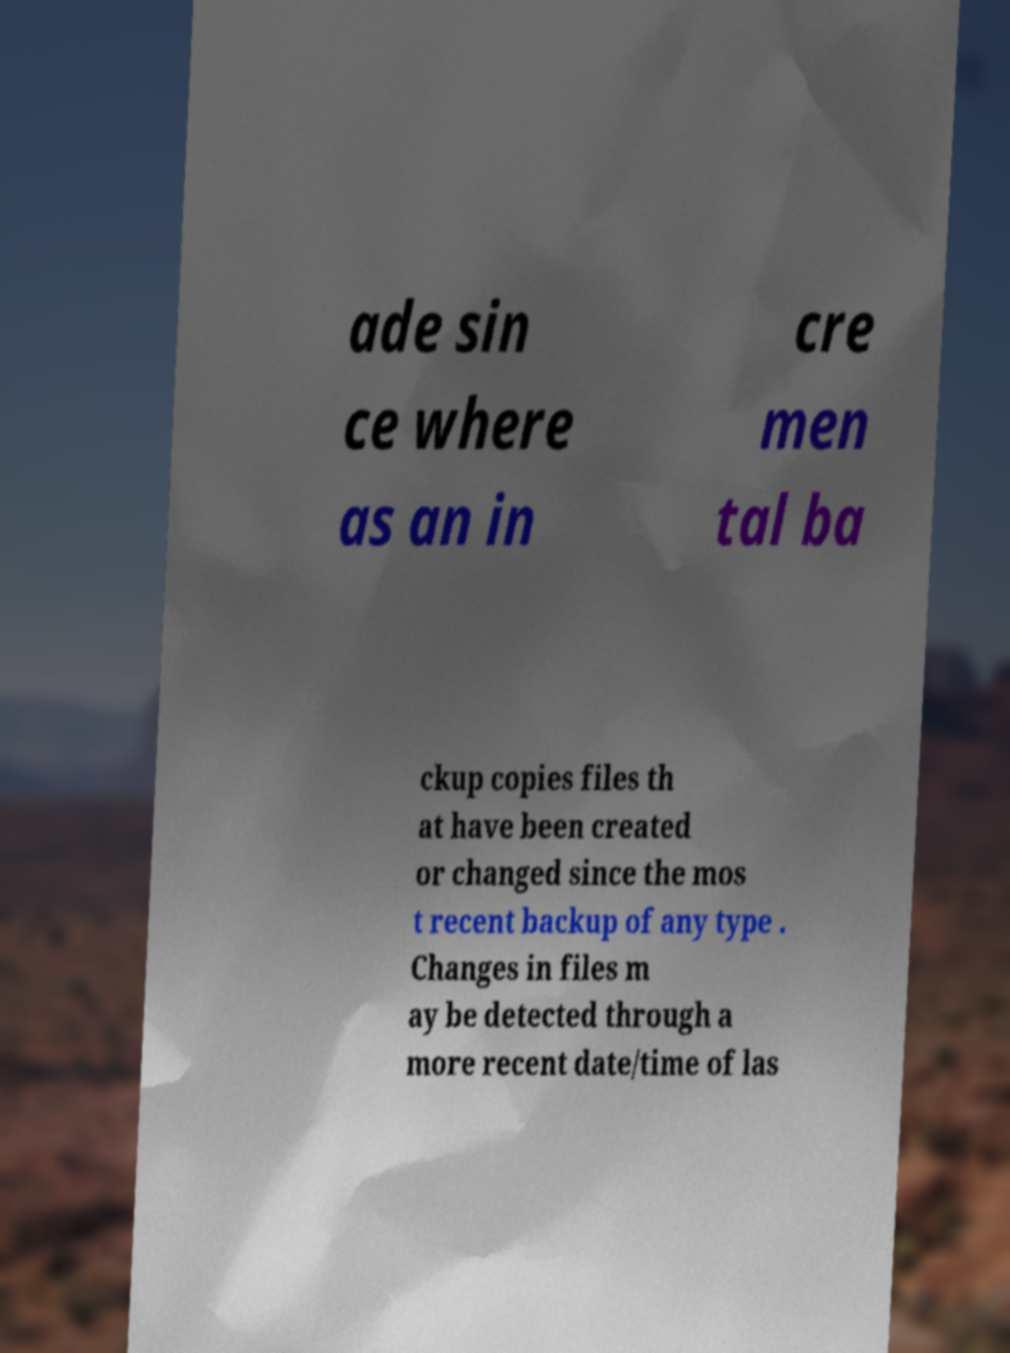Please read and relay the text visible in this image. What does it say? ade sin ce where as an in cre men tal ba ckup copies files th at have been created or changed since the mos t recent backup of any type . Changes in files m ay be detected through a more recent date/time of las 